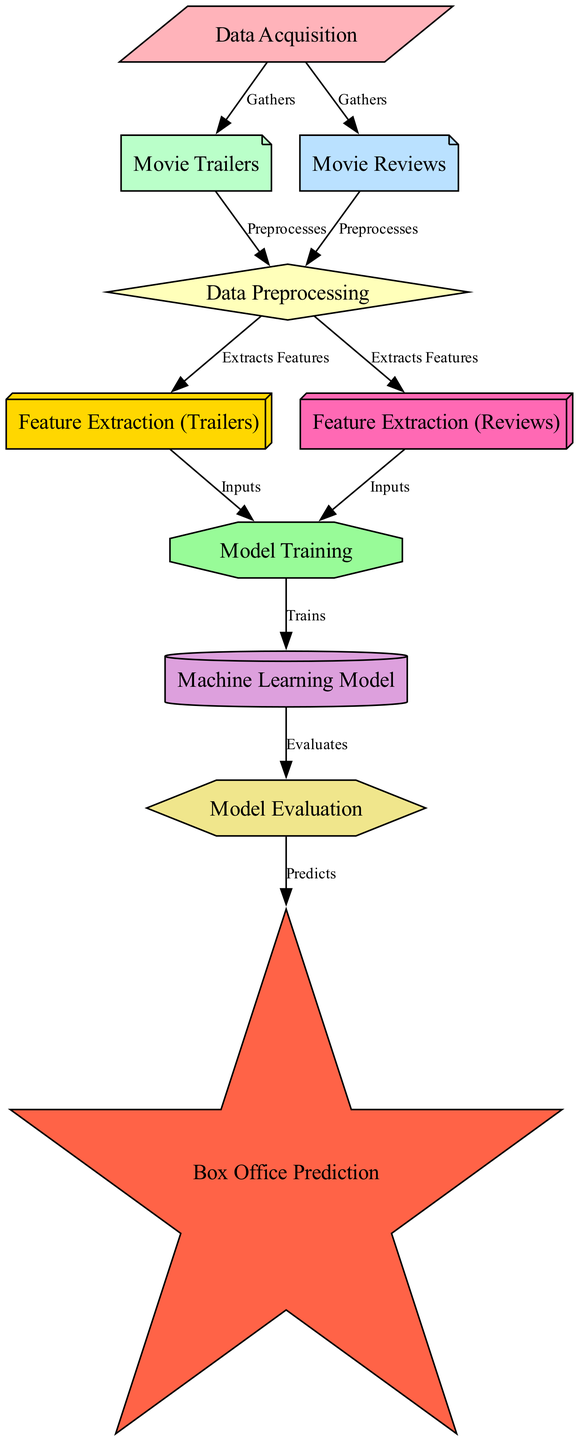What is the first step in the process? According to the diagram, the first step is "Data Acquisition," which gathers movie trailers and reviews.
Answer: Data Acquisition How many edges are in the diagram? By counting the connections shown in the diagram, there are a total of 11 edges.
Answer: 11 What does "Model Training" connect to? The "Model Training" node has edges leading to the "Machine Learning Model," indicating that it trains that model using features extracted from trailers and reviews.
Answer: Machine Learning Model Which nodes are involved in feature extraction? The diagram shows two nodes, "Feature Extraction (Trailers)" and "Feature Extraction (Reviews)," that relate to the feature extraction processes.
Answer: Feature Extraction (Trailers) and Feature Extraction (Reviews) What is the outcome of "Model Evaluation"? The diagram indicates that the output from the "Model Evaluation" node leads to "Box Office Prediction," meaning that this step predicts the success of the movie.
Answer: Box Office Prediction How do movie trailers contribute to the process? Movie trailers go from the "Data Acquisition" node through to "Data Preprocessing" and then to "Feature Extraction (Trailers)," which are essential steps to derive meaningful features for model training.
Answer: They provide input for feature extraction How many nodes focus on extraction? The diagram illustrates that there are two nodes specifically dedicated to extraction: "Feature Extraction (Trailers)" and "Feature Extraction (Reviews)."
Answer: 2 What kind of model is being evaluated? The diagram states that a "Machine Learning Model" is being evaluated, which is trained on the extracted features.
Answer: Machine Learning Model In what shape is "Data Preprocessing" represented? Looking at the diagram, "Data Preprocessing" is depicted as a diamond shape, indicating its critical function in the workflow.
Answer: Diamond 